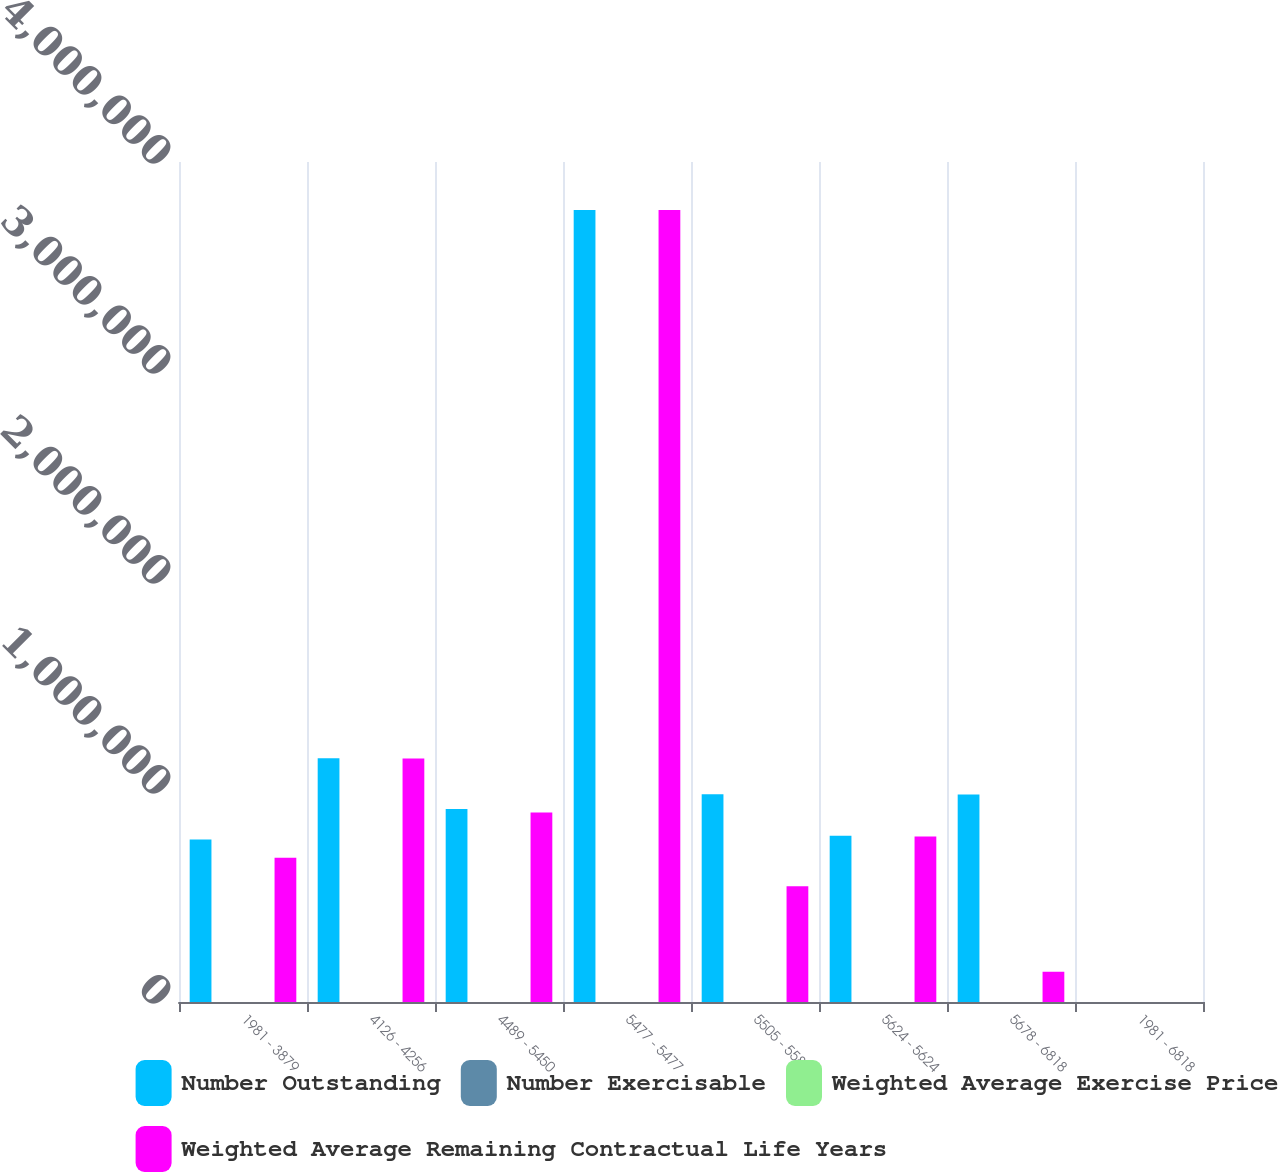<chart> <loc_0><loc_0><loc_500><loc_500><stacked_bar_chart><ecel><fcel>1981 - 3879<fcel>4126 - 4256<fcel>4489 - 5450<fcel>5477 - 5477<fcel>5505 - 5580<fcel>5624 - 5624<fcel>5678 - 6818<fcel>1981 - 6818<nl><fcel>Number Outstanding<fcel>773809<fcel>1.16071e+06<fcel>919008<fcel>3.77143e+06<fcel>989156<fcel>791942<fcel>987862<fcel>60.18<nl><fcel>Number Exercisable<fcel>4.04<fcel>3.58<fcel>5.54<fcel>4.22<fcel>4.81<fcel>6.51<fcel>6.41<fcel>4.74<nl><fcel>Weighted Average Exercise Price<fcel>35.81<fcel>41.26<fcel>45.35<fcel>54.77<fcel>55.49<fcel>56.24<fcel>64.12<fcel>51.8<nl><fcel>Weighted Average Remaining Contractual Life Years<fcel>687500<fcel>1.1592e+06<fcel>902443<fcel>3.77143e+06<fcel>550848<fcel>788361<fcel>144062<fcel>60.18<nl></chart> 